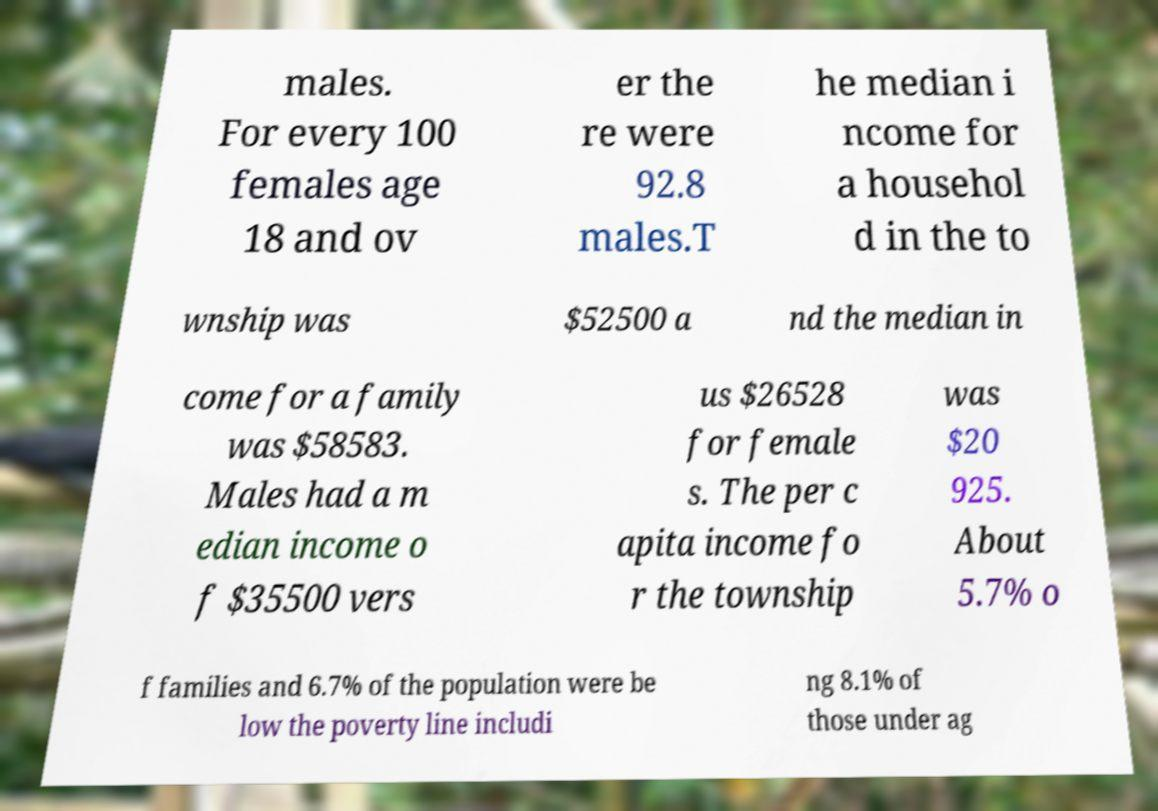Can you read and provide the text displayed in the image?This photo seems to have some interesting text. Can you extract and type it out for me? males. For every 100 females age 18 and ov er the re were 92.8 males.T he median i ncome for a househol d in the to wnship was $52500 a nd the median in come for a family was $58583. Males had a m edian income o f $35500 vers us $26528 for female s. The per c apita income fo r the township was $20 925. About 5.7% o f families and 6.7% of the population were be low the poverty line includi ng 8.1% of those under ag 